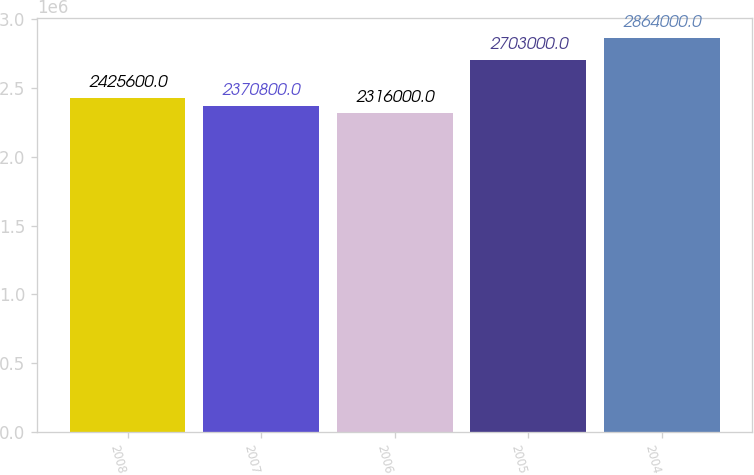<chart> <loc_0><loc_0><loc_500><loc_500><bar_chart><fcel>2008<fcel>2007<fcel>2006<fcel>2005<fcel>2004<nl><fcel>2.4256e+06<fcel>2.3708e+06<fcel>2.316e+06<fcel>2.703e+06<fcel>2.864e+06<nl></chart> 